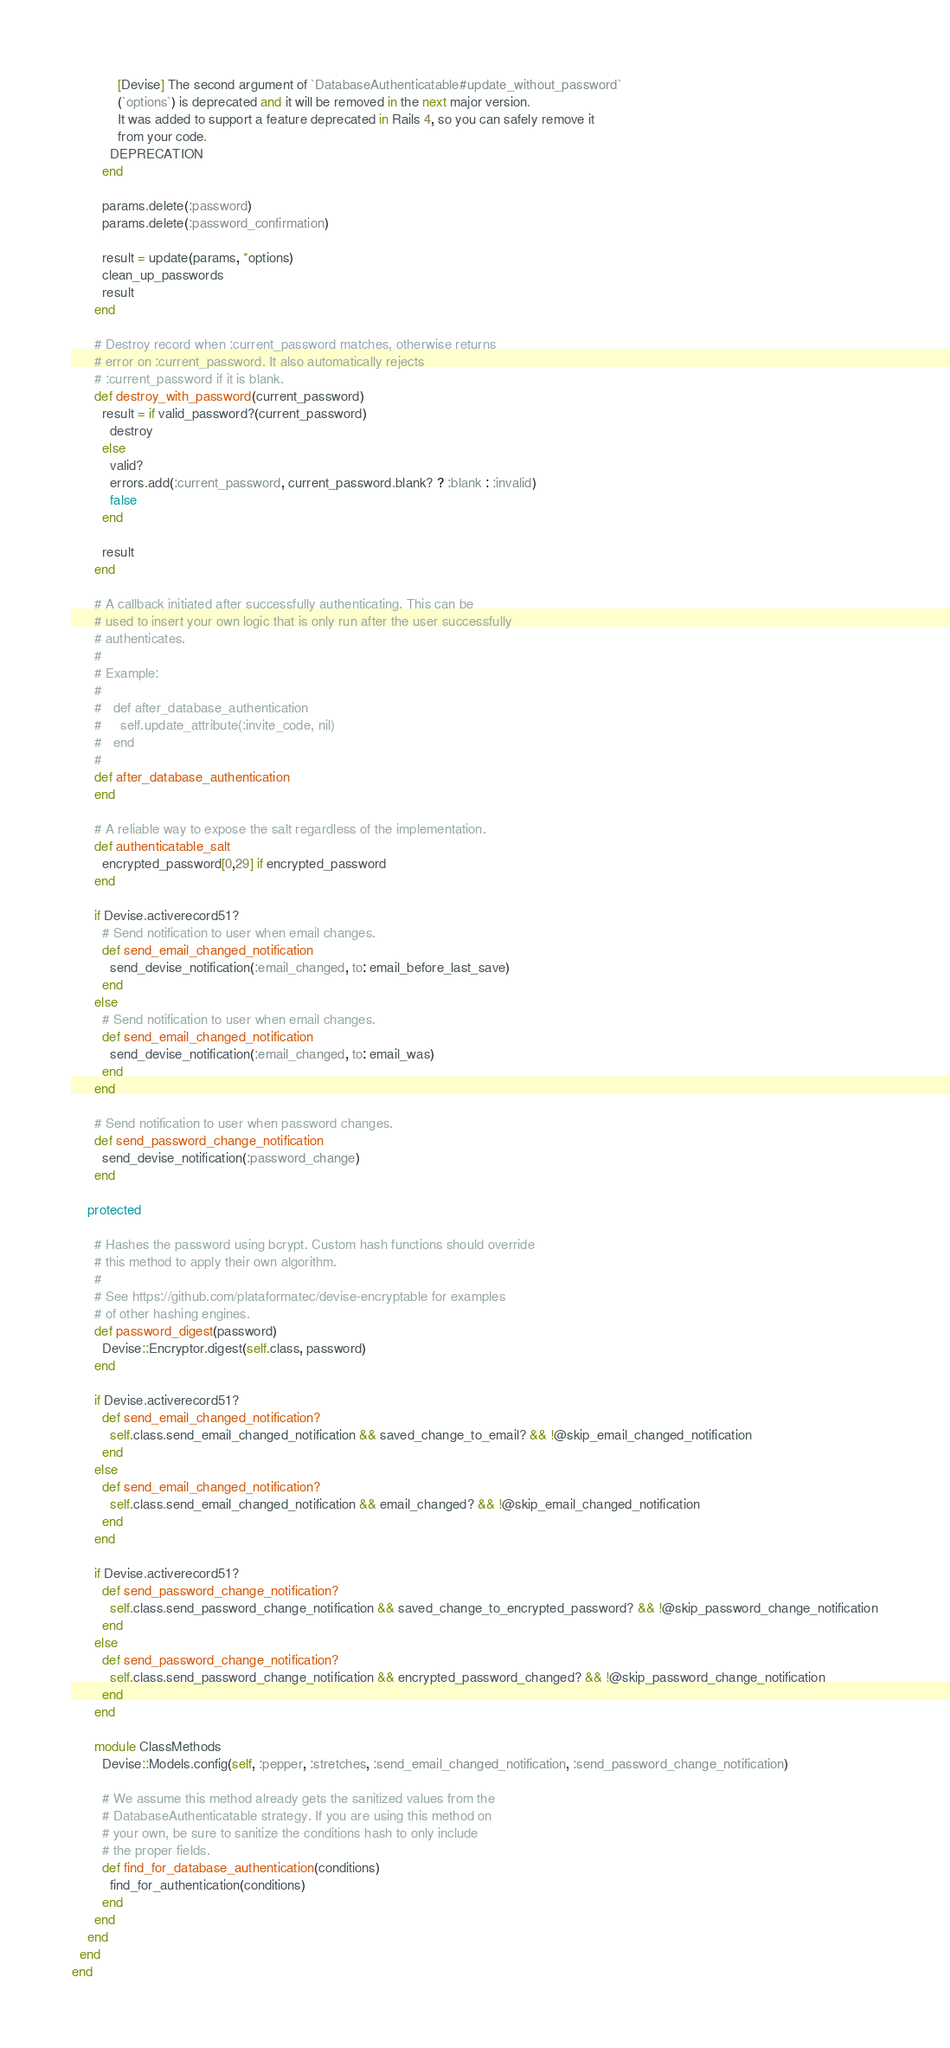Convert code to text. <code><loc_0><loc_0><loc_500><loc_500><_Ruby_>            [Devise] The second argument of `DatabaseAuthenticatable#update_without_password`
            (`options`) is deprecated and it will be removed in the next major version.
            It was added to support a feature deprecated in Rails 4, so you can safely remove it
            from your code.
          DEPRECATION
        end

        params.delete(:password)
        params.delete(:password_confirmation)

        result = update(params, *options)
        clean_up_passwords
        result
      end

      # Destroy record when :current_password matches, otherwise returns
      # error on :current_password. It also automatically rejects
      # :current_password if it is blank.
      def destroy_with_password(current_password)
        result = if valid_password?(current_password)
          destroy
        else
          valid?
          errors.add(:current_password, current_password.blank? ? :blank : :invalid)
          false
        end

        result
      end

      # A callback initiated after successfully authenticating. This can be
      # used to insert your own logic that is only run after the user successfully
      # authenticates.
      #
      # Example:
      #
      #   def after_database_authentication
      #     self.update_attribute(:invite_code, nil)
      #   end
      #
      def after_database_authentication
      end

      # A reliable way to expose the salt regardless of the implementation.
      def authenticatable_salt
        encrypted_password[0,29] if encrypted_password
      end

      if Devise.activerecord51?
        # Send notification to user when email changes.
        def send_email_changed_notification
          send_devise_notification(:email_changed, to: email_before_last_save)
        end
      else
        # Send notification to user when email changes.
        def send_email_changed_notification
          send_devise_notification(:email_changed, to: email_was)
        end
      end

      # Send notification to user when password changes.
      def send_password_change_notification
        send_devise_notification(:password_change)
      end

    protected

      # Hashes the password using bcrypt. Custom hash functions should override
      # this method to apply their own algorithm.
      #
      # See https://github.com/plataformatec/devise-encryptable for examples
      # of other hashing engines.
      def password_digest(password)
        Devise::Encryptor.digest(self.class, password)
      end

      if Devise.activerecord51?
        def send_email_changed_notification?
          self.class.send_email_changed_notification && saved_change_to_email? && !@skip_email_changed_notification
        end
      else
        def send_email_changed_notification?
          self.class.send_email_changed_notification && email_changed? && !@skip_email_changed_notification
        end
      end

      if Devise.activerecord51?
        def send_password_change_notification?
          self.class.send_password_change_notification && saved_change_to_encrypted_password? && !@skip_password_change_notification
        end
      else
        def send_password_change_notification?
          self.class.send_password_change_notification && encrypted_password_changed? && !@skip_password_change_notification
        end
      end

      module ClassMethods
        Devise::Models.config(self, :pepper, :stretches, :send_email_changed_notification, :send_password_change_notification)

        # We assume this method already gets the sanitized values from the
        # DatabaseAuthenticatable strategy. If you are using this method on
        # your own, be sure to sanitize the conditions hash to only include
        # the proper fields.
        def find_for_database_authentication(conditions)
          find_for_authentication(conditions)
        end
      end
    end
  end
end
</code> 